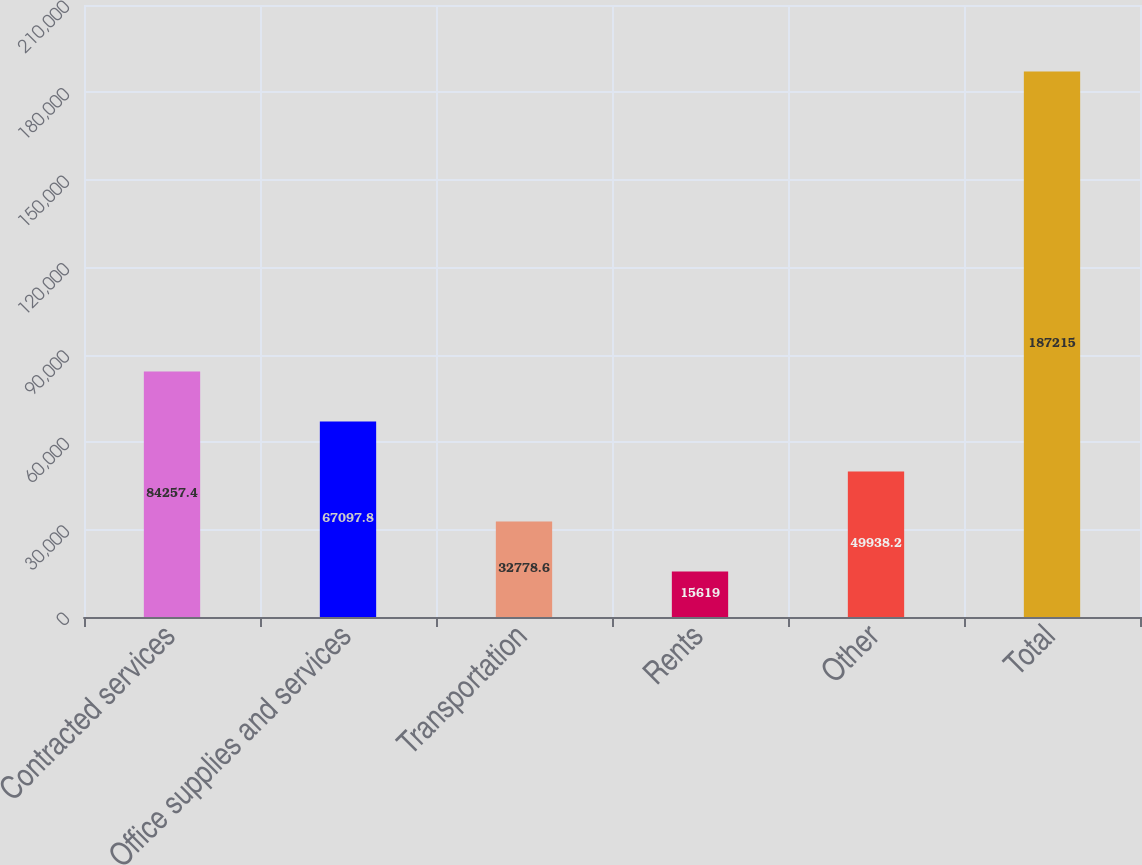Convert chart to OTSL. <chart><loc_0><loc_0><loc_500><loc_500><bar_chart><fcel>Contracted services<fcel>Office supplies and services<fcel>Transportation<fcel>Rents<fcel>Other<fcel>Total<nl><fcel>84257.4<fcel>67097.8<fcel>32778.6<fcel>15619<fcel>49938.2<fcel>187215<nl></chart> 